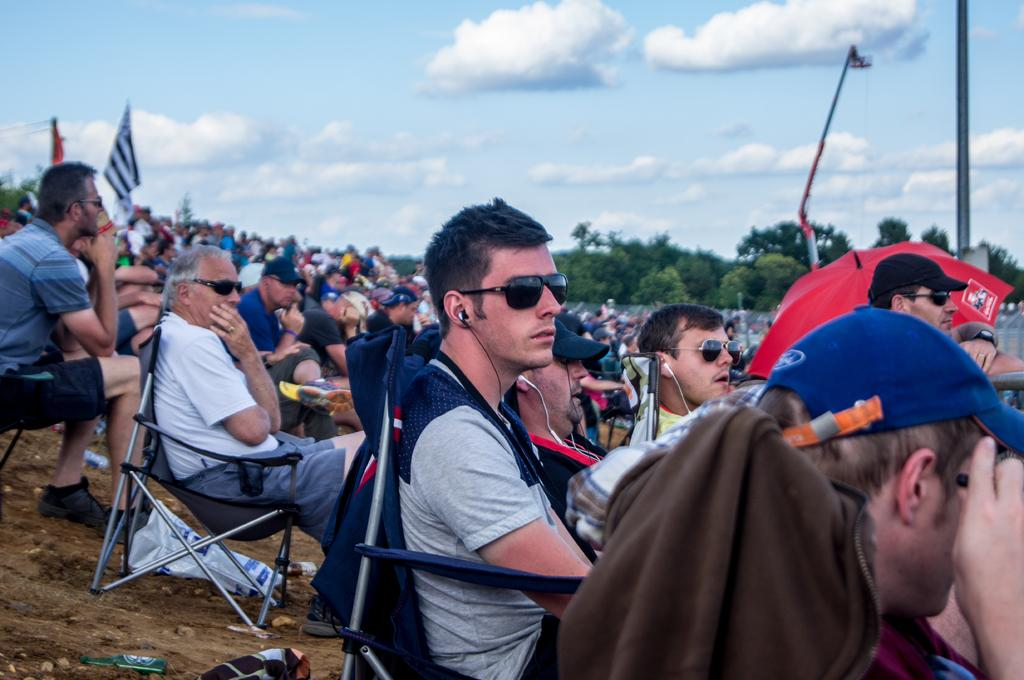What are the people in the image doing? There is a group of people sitting in chairs. What can be seen in the background of the image? There are trees in the image. What object is present in the image that is not related to the people or trees? There is a pole in the image. What is visible in the sky in the image? Trees are visible in the sky. What is hanging in the image? There is a flag hanging in the image. Can you see the people in the image breathing? The image does not show the people breathing; it only shows their physical appearance and position. 